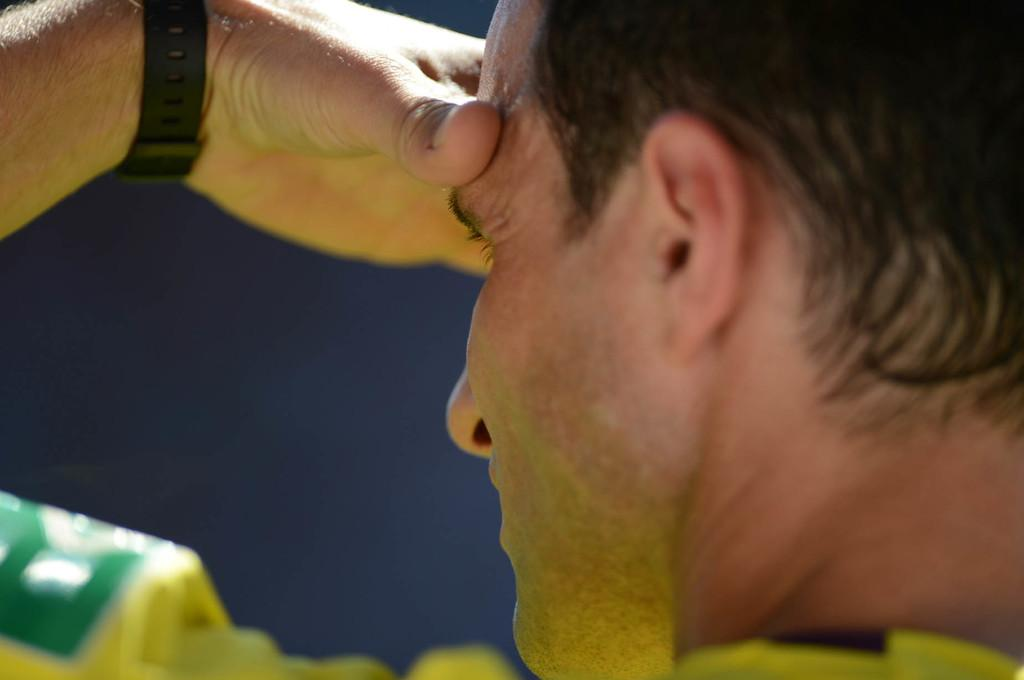Who or what is the main subject of the image? There is a person in the image. What color is the background of the image? The background of the image is navy blue. What accessory is the person wearing in the image? The person is wearing a wrist watch. What type of seed can be seen growing in the image? There is no seed or plant visible in the image; it features a person with a navy blue background and a wrist watch. 